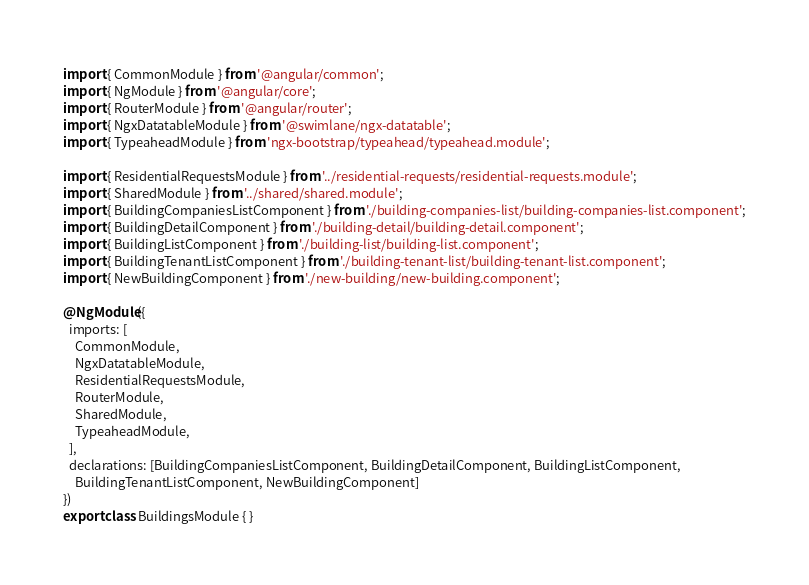<code> <loc_0><loc_0><loc_500><loc_500><_TypeScript_>import { CommonModule } from '@angular/common';
import { NgModule } from '@angular/core';
import { RouterModule } from '@angular/router';
import { NgxDatatableModule } from '@swimlane/ngx-datatable';
import { TypeaheadModule } from 'ngx-bootstrap/typeahead/typeahead.module';

import { ResidentialRequestsModule } from '../residential-requests/residential-requests.module';
import { SharedModule } from '../shared/shared.module';
import { BuildingCompaniesListComponent } from './building-companies-list/building-companies-list.component';
import { BuildingDetailComponent } from './building-detail/building-detail.component';
import { BuildingListComponent } from './building-list/building-list.component';
import { BuildingTenantListComponent } from './building-tenant-list/building-tenant-list.component';
import { NewBuildingComponent } from './new-building/new-building.component';

@NgModule({
  imports: [
    CommonModule,
    NgxDatatableModule,
    ResidentialRequestsModule,
    RouterModule,
    SharedModule,
    TypeaheadModule,
  ],
  declarations: [BuildingCompaniesListComponent, BuildingDetailComponent, BuildingListComponent,
    BuildingTenantListComponent, NewBuildingComponent]
})
export class BuildingsModule { }
</code> 